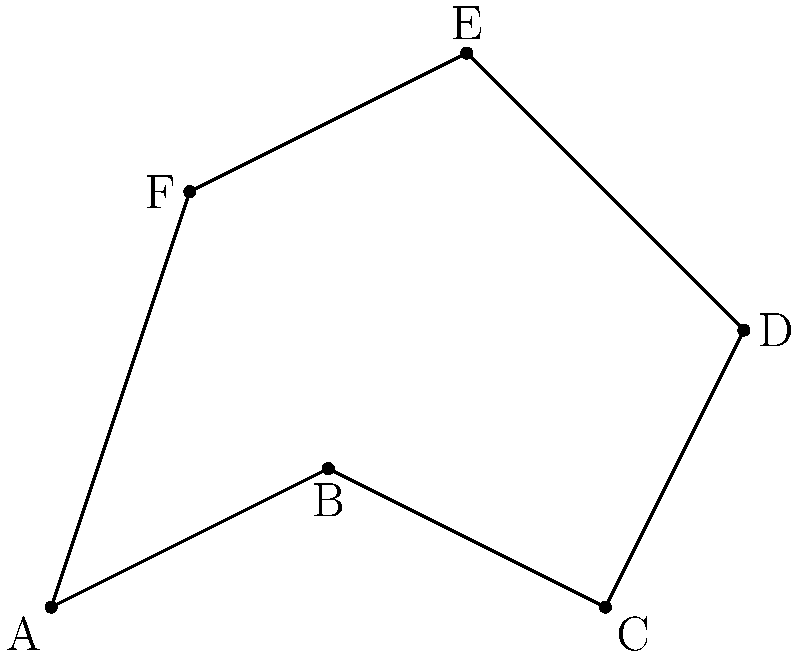In a leaked map of an irregularly shaped voting district, the boundaries are defined by the coordinates A(0,0), B(2,1), C(4,0), D(5,2), E(3,4), and F(1,3). Calculate the perimeter and area of this district. How might these irregular boundaries potentially indicate gerrymandering? To calculate the perimeter and area of the irregular voting district:

1. Perimeter calculation:
   Use the distance formula between consecutive points:
   $$d = \sqrt{(x_2-x_1)^2 + (y_2-y_1)^2}$$
   AB = $\sqrt{(2-0)^2 + (1-0)^2} = \sqrt{5}$
   BC = $\sqrt{(4-2)^2 + (0-1)^2} = \sqrt{5}$
   CD = $\sqrt{(5-4)^2 + (2-0)^2} = \sqrt{5}$
   DE = $\sqrt{(3-5)^2 + (4-2)^2} = 2\sqrt{2}$
   EF = $\sqrt{(1-3)^2 + (3-4)^2} = \sqrt{5}$
   FA = $\sqrt{(0-1)^2 + (0-3)^2} = \sqrt{10}$

   Total perimeter = $3\sqrt{5} + 2\sqrt{2} + \sqrt{10} \approx 11.64$ units

2. Area calculation:
   Use the Shoelace formula: $A = \frac{1}{2}|\sum_{i=1}^{n-1} (x_iy_{i+1} - x_{i+1}y_i) + (x_ny_1 - x_1y_n)|$

   $A = \frac{1}{2}|(0 \cdot 1 + 2 \cdot 0 + 4 \cdot 2 + 5 \cdot 4 + 3 \cdot 3 + 1 \cdot 0) - (2 \cdot 0 + 4 \cdot 1 + 5 \cdot 2 + 3 \cdot 4 + 1 \cdot 3 + 0 \cdot 0)|$
   $A = \frac{1}{2}|(0 + 0 + 8 + 20 + 9 + 0) - (0 + 4 + 10 + 12 + 3 + 0)|$
   $A = \frac{1}{2}|37 - 29| = \frac{1}{2} \cdot 8 = 4$ square units

3. Potential indication of gerrymandering:
   The irregular shape with narrow connections and protrusions could indicate attempts to include or exclude specific populations. The perimeter-to-area ratio is relatively high, which is often a sign of gerrymandering. A more compact, regular shape would typically have a lower perimeter-to-area ratio.
Answer: Perimeter: $3\sqrt{5} + 2\sqrt{2} + \sqrt{10} \approx 11.64$ units; Area: 4 square units; High perimeter-to-area ratio suggests potential gerrymandering. 